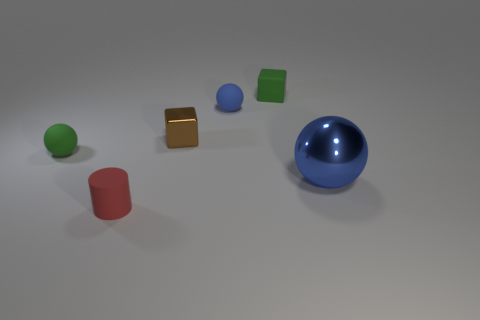Subtract all blue balls. How many were subtracted if there are1blue balls left? 1 Add 2 tiny things. How many objects exist? 8 Subtract all cubes. How many objects are left? 4 Subtract 1 green cubes. How many objects are left? 5 Subtract all large brown spheres. Subtract all blue balls. How many objects are left? 4 Add 6 tiny blue rubber balls. How many tiny blue rubber balls are left? 7 Add 2 small cyan cubes. How many small cyan cubes exist? 2 